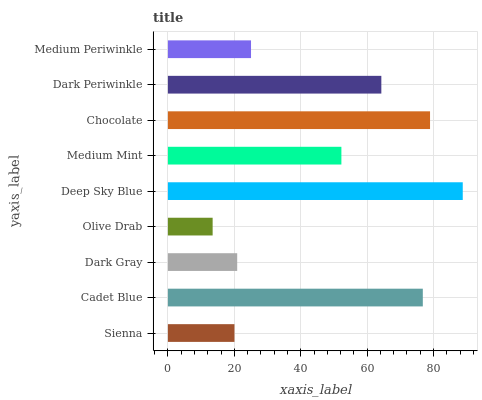Is Olive Drab the minimum?
Answer yes or no. Yes. Is Deep Sky Blue the maximum?
Answer yes or no. Yes. Is Cadet Blue the minimum?
Answer yes or no. No. Is Cadet Blue the maximum?
Answer yes or no. No. Is Cadet Blue greater than Sienna?
Answer yes or no. Yes. Is Sienna less than Cadet Blue?
Answer yes or no. Yes. Is Sienna greater than Cadet Blue?
Answer yes or no. No. Is Cadet Blue less than Sienna?
Answer yes or no. No. Is Medium Mint the high median?
Answer yes or no. Yes. Is Medium Mint the low median?
Answer yes or no. Yes. Is Sienna the high median?
Answer yes or no. No. Is Olive Drab the low median?
Answer yes or no. No. 